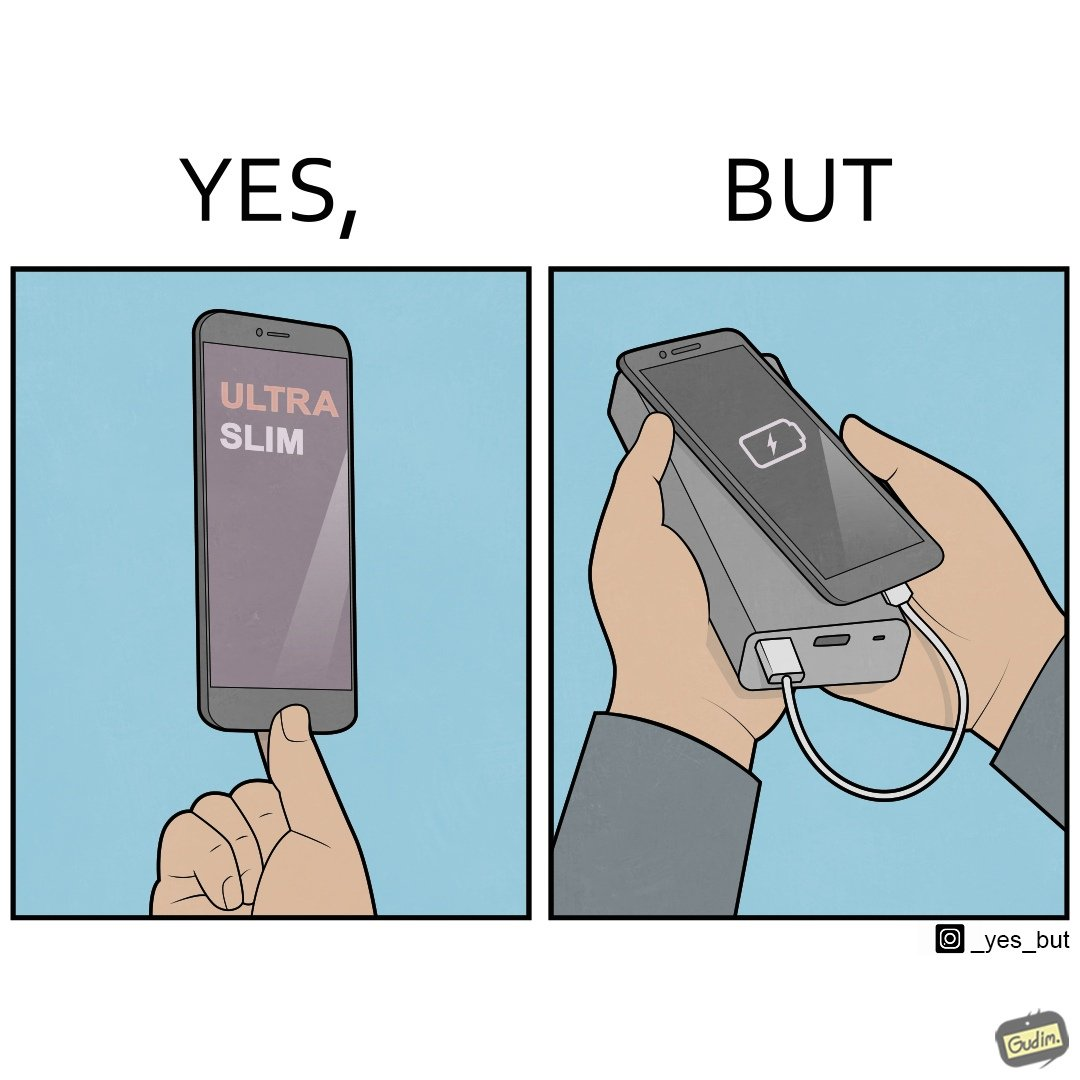What does this image depict? The image is satirical because even though the mobile phone has been developed to be very slim, it requires frequent recharging which makes the mobile phone useless without a big, heavy and thick power bank. 